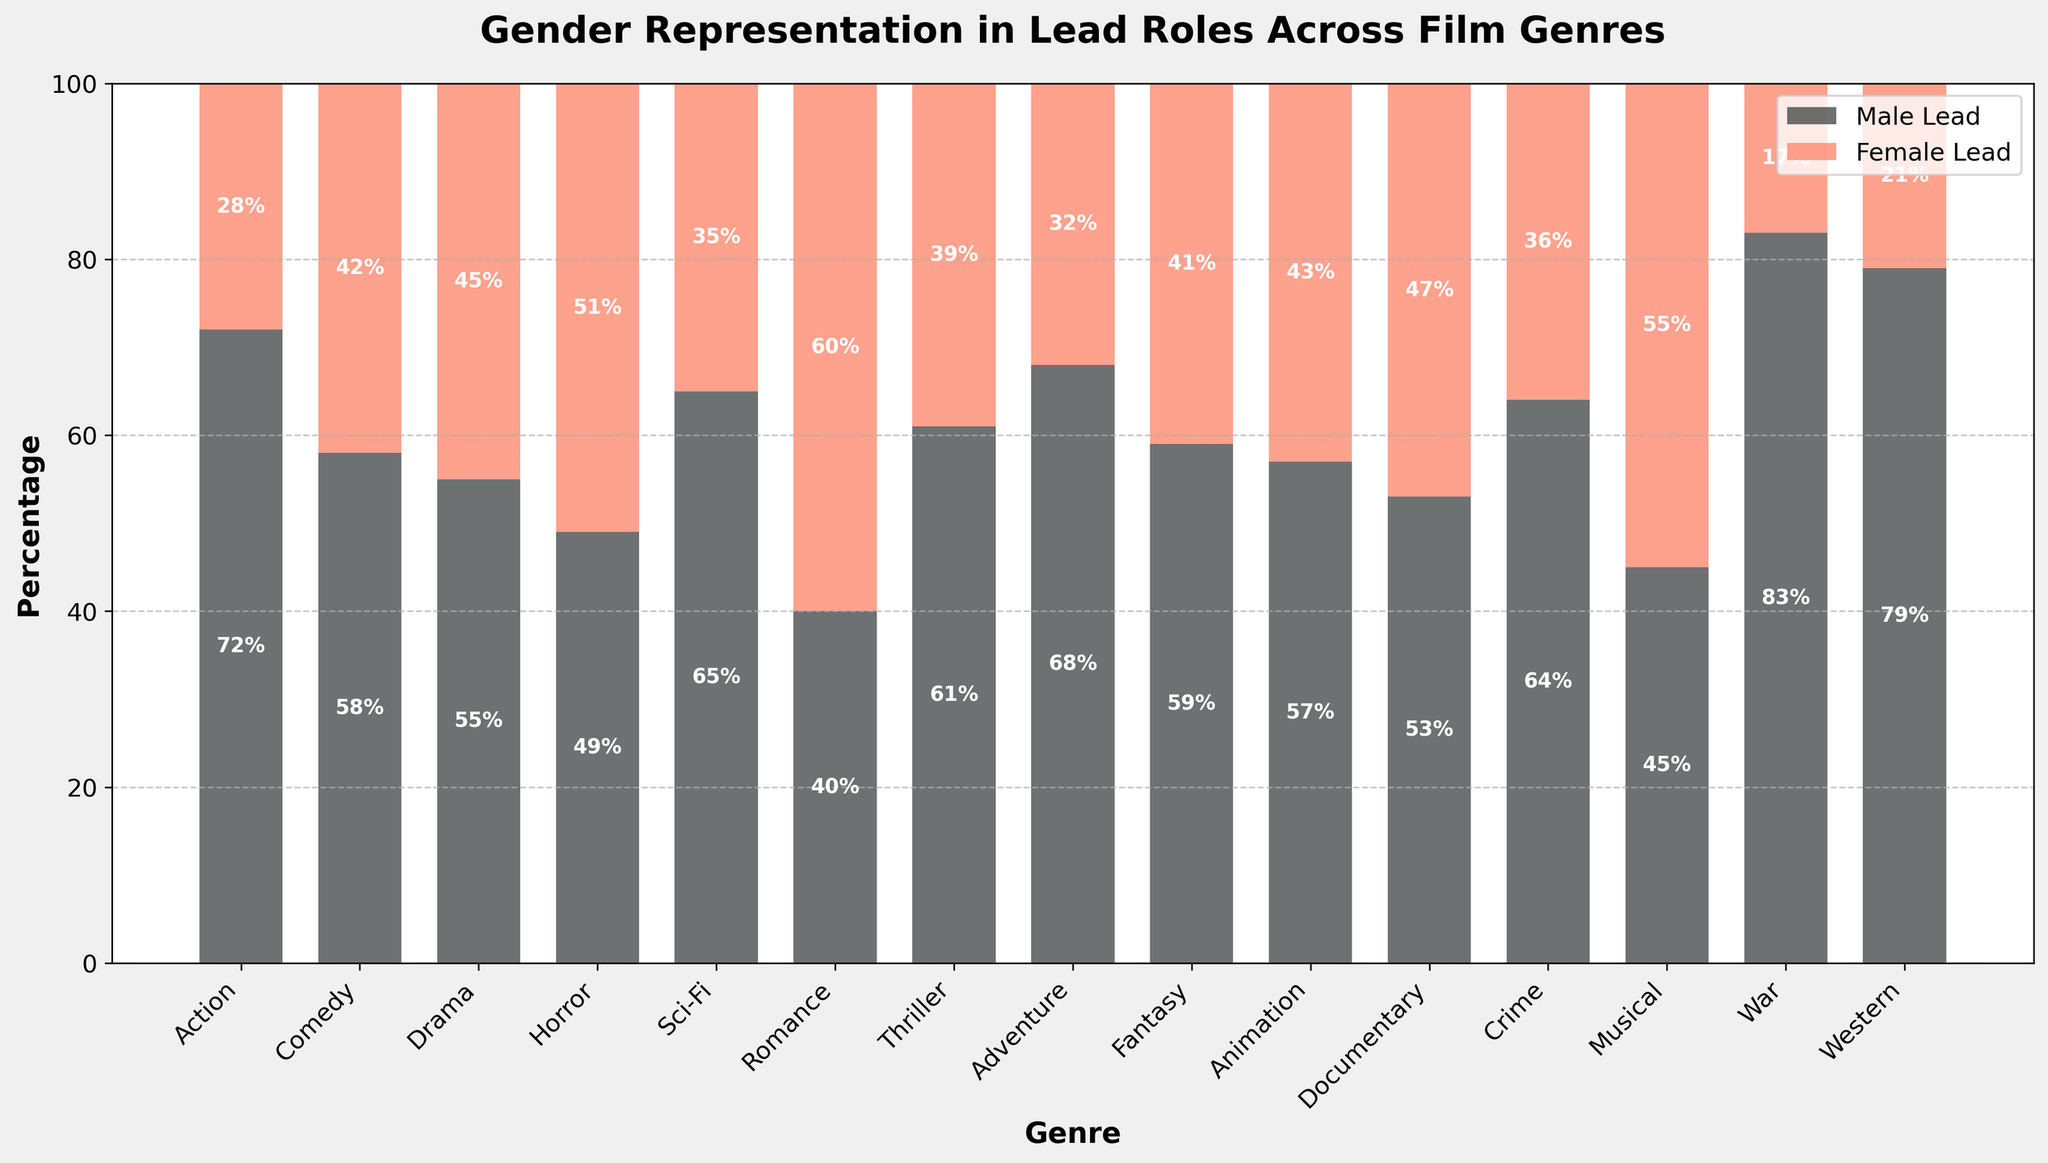Which genre has the highest percentage of male lead roles? By looking at the height of the bars representing male lead roles, the genre with the highest percentage is War, where the bar reaches 83%.
Answer: War Which genre has a higher percentage of female lead roles, Comedy or Adventure? By comparing the heights of the female lead bars, Comedy has a higher percentage (42%) than Adventure (32%).
Answer: Comedy What is the difference in percentage of female lead roles between Sci-Fi and Fantasy? The percentage of female lead roles in Sci-Fi is 35% and in Fantasy is 41%. The difference is calculated as 41% - 35% = 6%.
Answer: 6% What is the average percentage of female lead roles across Drama, Horror, and Romance genres? Sum the female lead percentages: 45% (Drama) + 51% (Horror) + 60% (Romance) = 156%. Then divide by 3: 156% / 3 = 52%.
Answer: 52% How many genres have a higher percentage of female lead roles than male lead roles? By visually inspecting the chart, only Horror (51% female) and Romance (60% female) have more female lead roles than male lead roles.
Answer: 2 Which genre has the smallest difference in lead role percentages between male and female? Calculate the differences for each genre and find the smallest: Horror (2% difference) has the smallest difference (51% female vs. 49% male).
Answer: Horror Is the percentage of female lead roles in Musicals higher or lower than in Documentaries? By comparing the heights, Musical has a higher percentage (55%) than Documentary (47%).
Answer: Higher Which genres have nearly equal representation (male vs. female lead roles), within 5% difference? Calculate the difference for each genre and find those within 5%: Horror (2%), Documentary (6% but within 5% cutoff).
Answer: Horror Which genre shows the greatest gender disparity in lead roles, and what is the percentage difference? Calculate the difference for each genre and find the greatest: War has the greatest disparity with 83% male vs. 17% female, an absolute difference of 66%.
Answer: War, 66% 